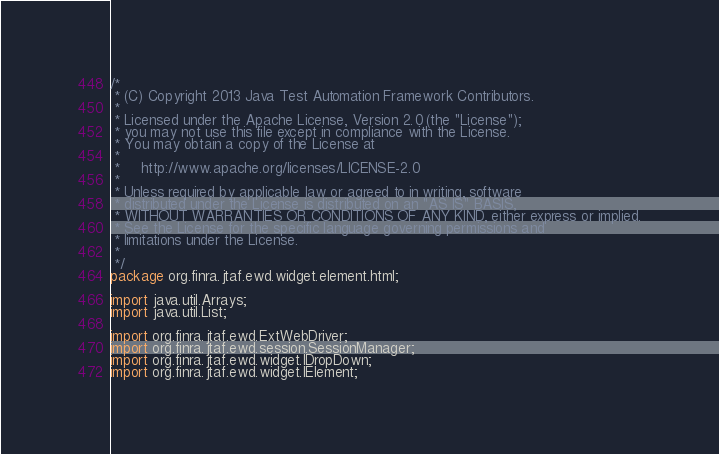<code> <loc_0><loc_0><loc_500><loc_500><_Java_>/*
 * (C) Copyright 2013 Java Test Automation Framework Contributors.
 *
 * Licensed under the Apache License, Version 2.0 (the "License");
 * you may not use this file except in compliance with the License.
 * You may obtain a copy of the License at
 *
 *     http://www.apache.org/licenses/LICENSE-2.0
 *
 * Unless required by applicable law or agreed to in writing, software
 * distributed under the License is distributed on an "AS IS" BASIS,
 * WITHOUT WARRANTIES OR CONDITIONS OF ANY KIND, either express or implied.
 * See the License for the specific language governing permissions and
 * limitations under the License.
 *
 */
package org.finra.jtaf.ewd.widget.element.html;

import java.util.Arrays;
import java.util.List;

import org.finra.jtaf.ewd.ExtWebDriver;
import org.finra.jtaf.ewd.session.SessionManager;
import org.finra.jtaf.ewd.widget.IDropDown;
import org.finra.jtaf.ewd.widget.IElement;</code> 